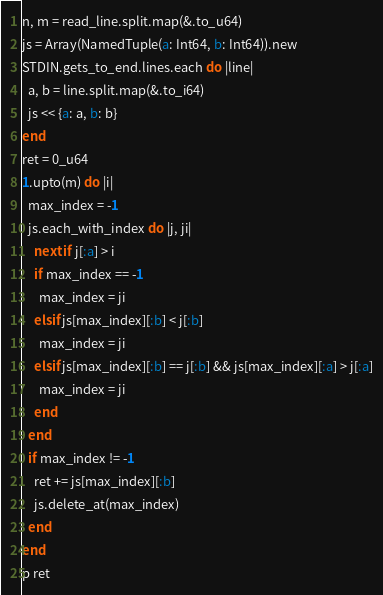Convert code to text. <code><loc_0><loc_0><loc_500><loc_500><_Crystal_>n, m = read_line.split.map(&.to_u64)
js = Array(NamedTuple(a: Int64, b: Int64)).new
STDIN.gets_to_end.lines.each do |line|
  a, b = line.split.map(&.to_i64)
  js << {a: a, b: b}
end
ret = 0_u64
1.upto(m) do |i|
  max_index = -1
  js.each_with_index do |j, ji|
    next if j[:a] > i
    if max_index == -1
      max_index = ji
    elsif js[max_index][:b] < j[:b]
      max_index = ji
    elsif js[max_index][:b] == j[:b] && js[max_index][:a] > j[:a]
      max_index = ji
    end
  end
  if max_index != -1
    ret += js[max_index][:b]
    js.delete_at(max_index)
  end
end
p ret</code> 